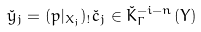<formula> <loc_0><loc_0><loc_500><loc_500>\check { y } _ { j } = ( p | _ { X _ { j } } ) _ { ! } \check { c } _ { j } \in \check { K } ^ { - i - n } _ { \Gamma } ( Y )</formula> 